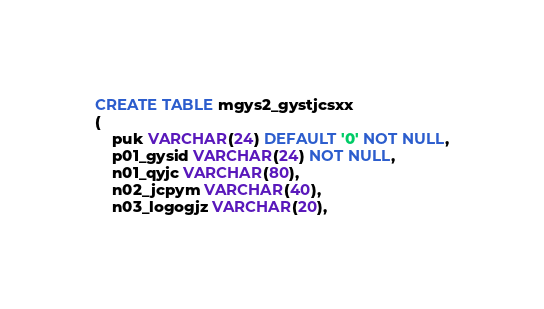<code> <loc_0><loc_0><loc_500><loc_500><_SQL_>CREATE TABLE mgys2_gystjcsxx
(
    puk VARCHAR(24) DEFAULT '0' NOT NULL,
    p01_gysid VARCHAR(24) NOT NULL,
    n01_qyjc VARCHAR(80),
    n02_jcpym VARCHAR(40),
    n03_logogjz VARCHAR(20),</code> 